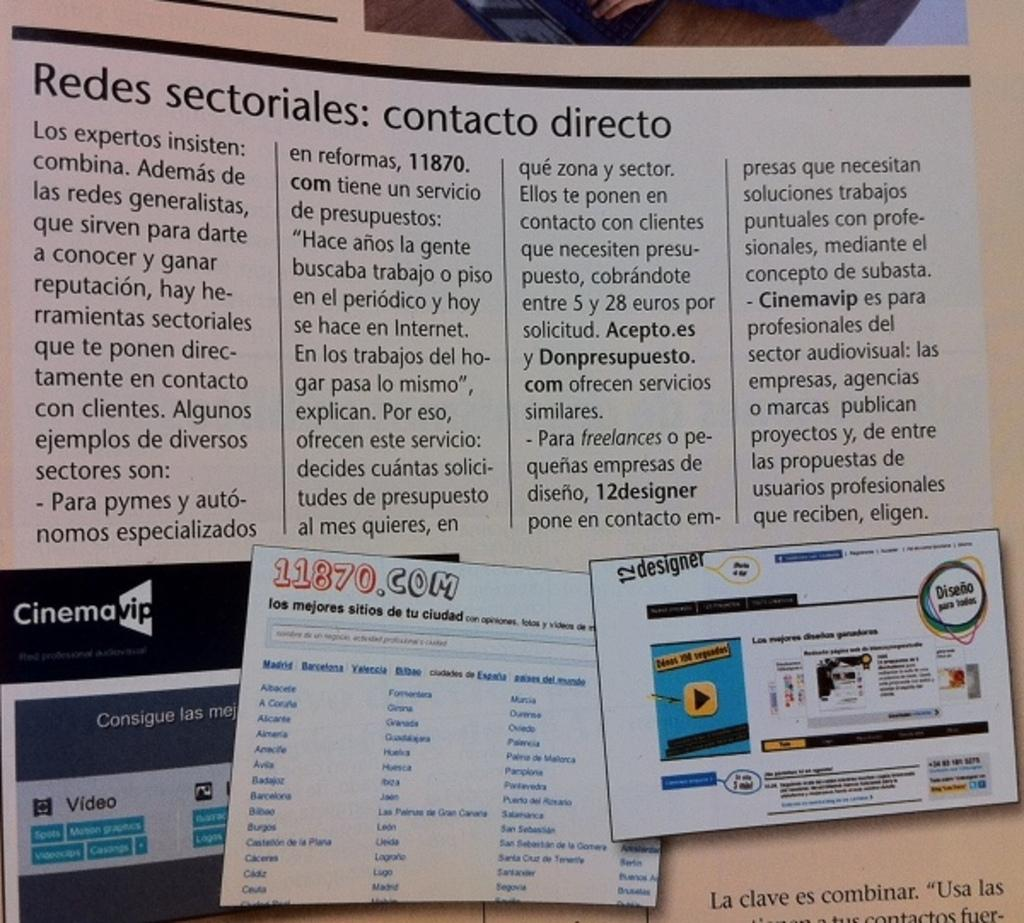<image>
Create a compact narrative representing the image presented. A magazine has an article that says Redes sectoriales: contacto directo. 